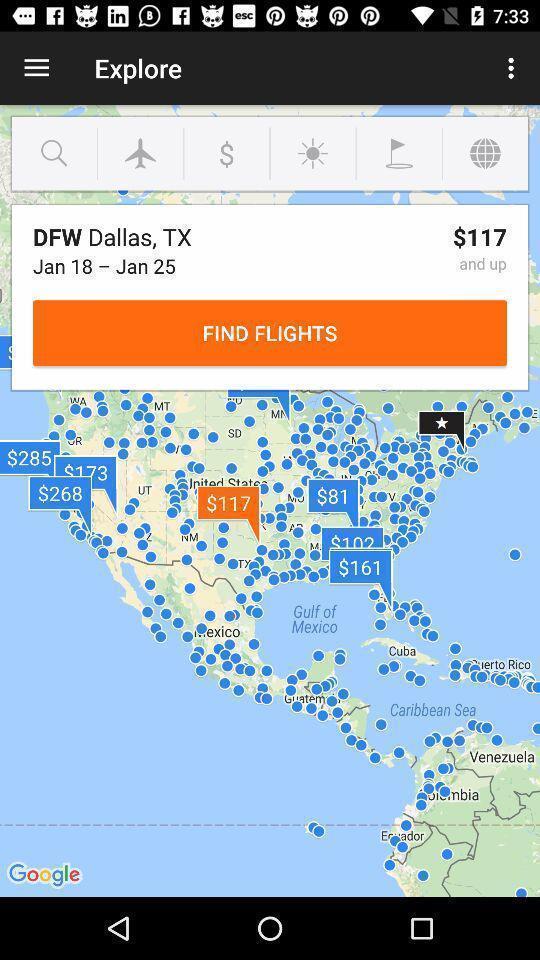Give me a summary of this screen capture. Page for searching flights within desired dates. 